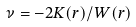<formula> <loc_0><loc_0><loc_500><loc_500>\nu = - 2 K ( r ) / W ( r )</formula> 